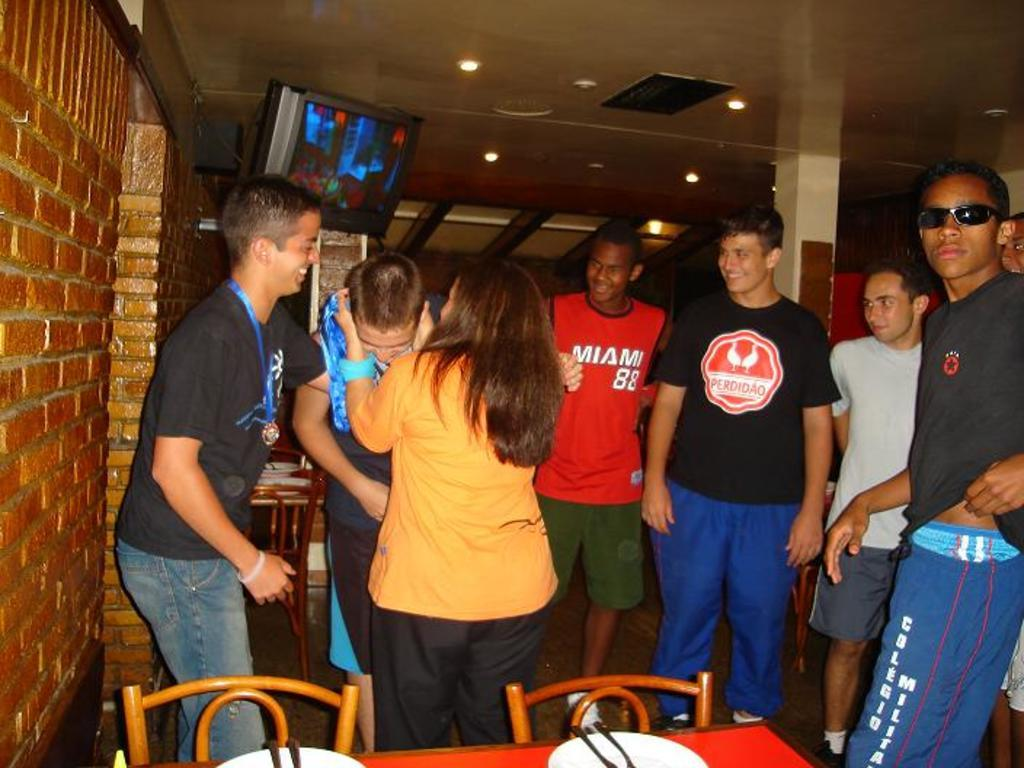What are the people in the image doing? The people in the image are laughing. What can be seen in the background of the image? There is a TV visible in the image. What type of furniture is present in the image? There is a table and a chair in the image. What type of liquid can be seen flowing from the ceiling in the image? There is no liquid flowing from the ceiling in the image. Can you describe the wave pattern on the floor in the image? There is no wave pattern on the floor in the image. 